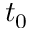Convert formula to latex. <formula><loc_0><loc_0><loc_500><loc_500>t _ { 0 }</formula> 